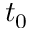Convert formula to latex. <formula><loc_0><loc_0><loc_500><loc_500>t _ { 0 }</formula> 